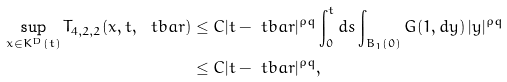Convert formula to latex. <formula><loc_0><loc_0><loc_500><loc_500>\sup _ { x \in K ^ { D } ( t ) } T _ { 4 , 2 , 2 } ( x , t , \ t b a r ) & \leq C | t - \ t b a r | ^ { \rho q } \int _ { 0 } ^ { t } d s \int _ { B _ { 1 } ( 0 ) } G ( 1 , d y ) \, | y | ^ { \rho q } \\ & \leq C | t - \ t b a r | ^ { \rho q } ,</formula> 